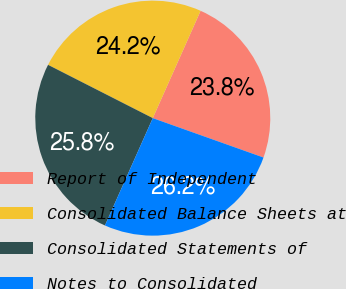Convert chart. <chart><loc_0><loc_0><loc_500><loc_500><pie_chart><fcel>Report of Independent<fcel>Consolidated Balance Sheets at<fcel>Consolidated Statements of<fcel>Notes to Consolidated<nl><fcel>23.77%<fcel>24.18%<fcel>25.82%<fcel>26.23%<nl></chart> 